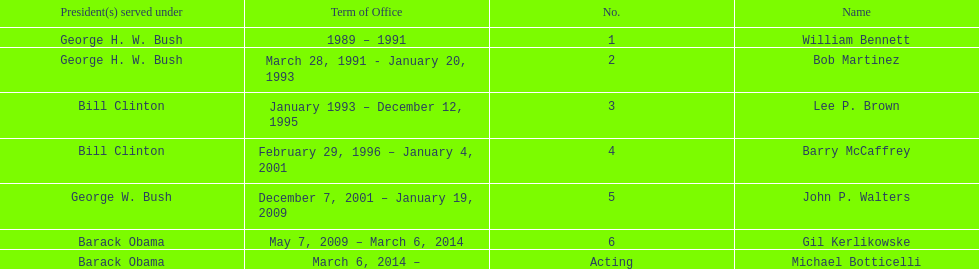What were the number of directors that stayed in office more than three years? 3. 